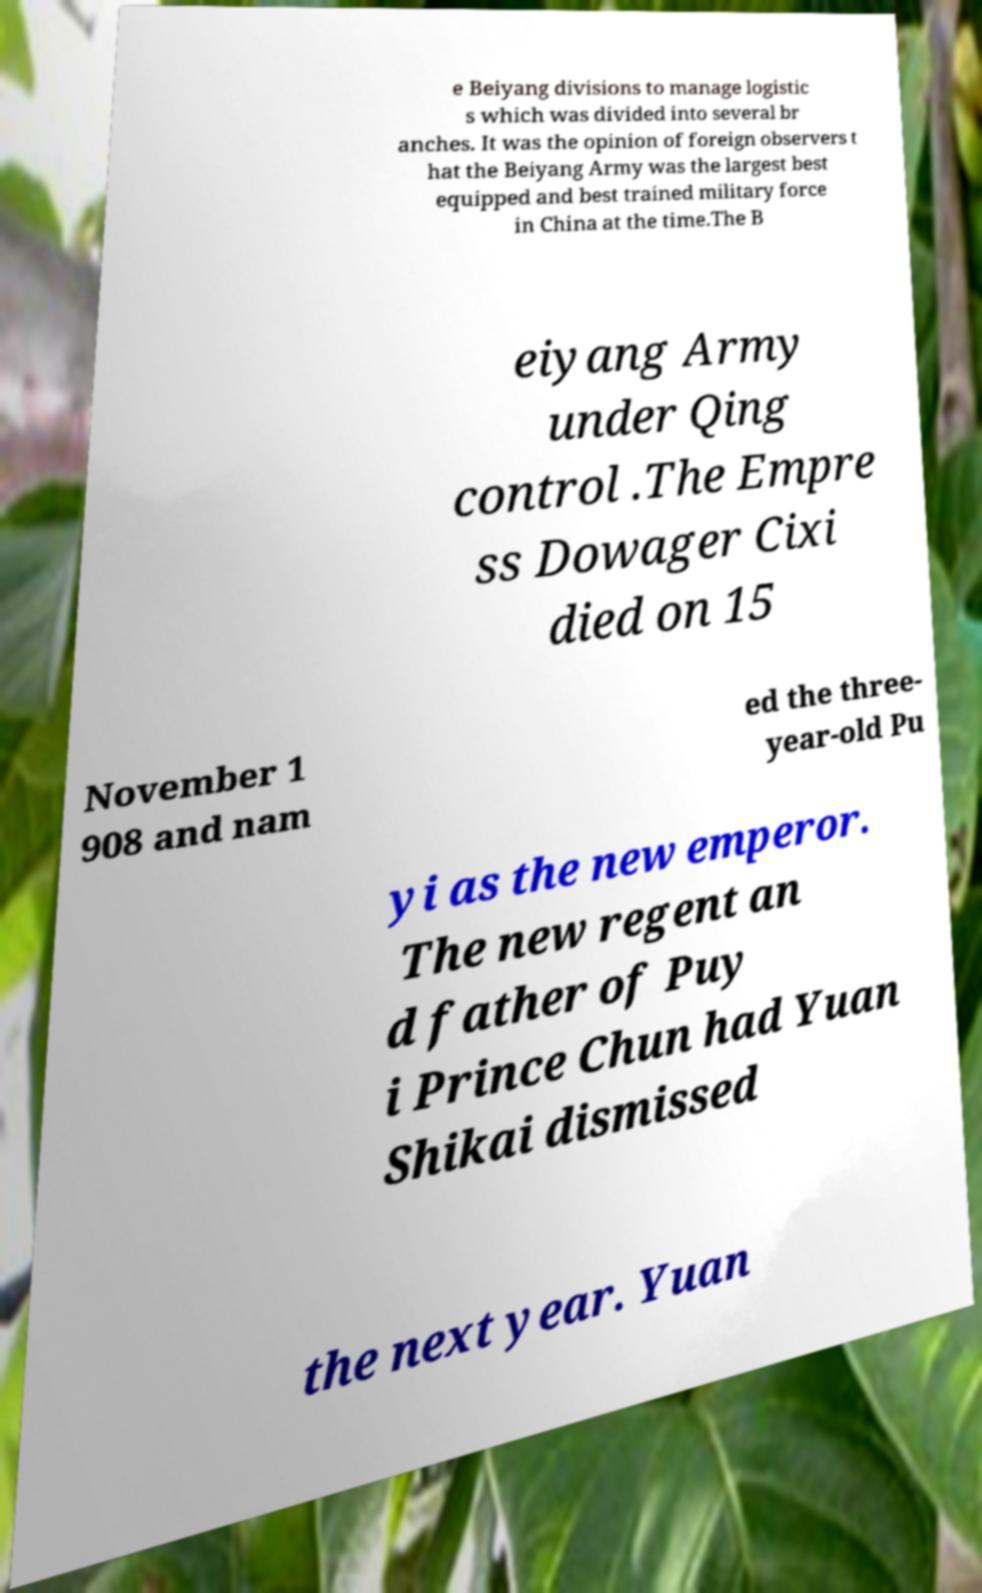Could you assist in decoding the text presented in this image and type it out clearly? e Beiyang divisions to manage logistic s which was divided into several br anches. It was the opinion of foreign observers t hat the Beiyang Army was the largest best equipped and best trained military force in China at the time.The B eiyang Army under Qing control .The Empre ss Dowager Cixi died on 15 November 1 908 and nam ed the three- year-old Pu yi as the new emperor. The new regent an d father of Puy i Prince Chun had Yuan Shikai dismissed the next year. Yuan 